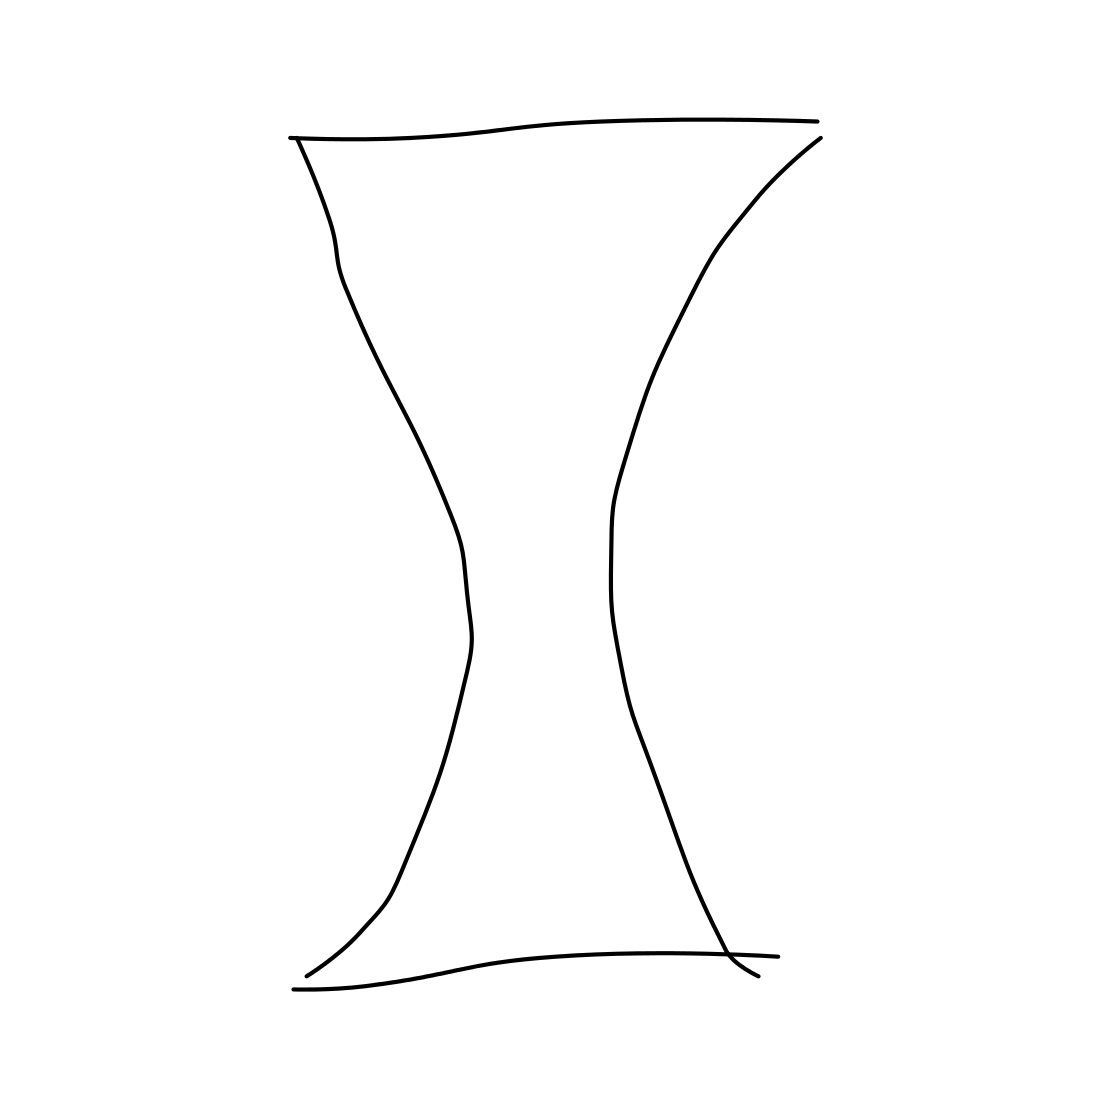Could this shape have a function if it were a real object? If this shape were a real, three-dimensional object, it could function as a vase or container due to its open top and bottom. Its form might also lend itself to being a decorative element in architecture or design. How might changing the proportions of the shape affect its perceived function? Altering the proportions could significantly impact its utility and aesthetics. For example, a narrower center might suggest a more delicate purpose, like holding a single flower stem. In contrast, a wider, more stable base might make it suitable for use as a lampshade or part of a candle holder. 